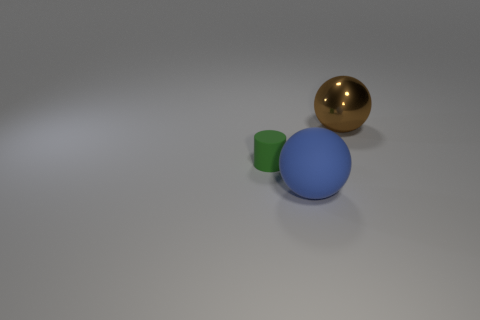Can you describe the sizes and colors of the objects in the image? Certainly! There are three objects in the image: a small green matte cylinder, a medium-sized blue matte sphere, and a large gold glossy sphere. The size contrast between them creates an interesting composition. 